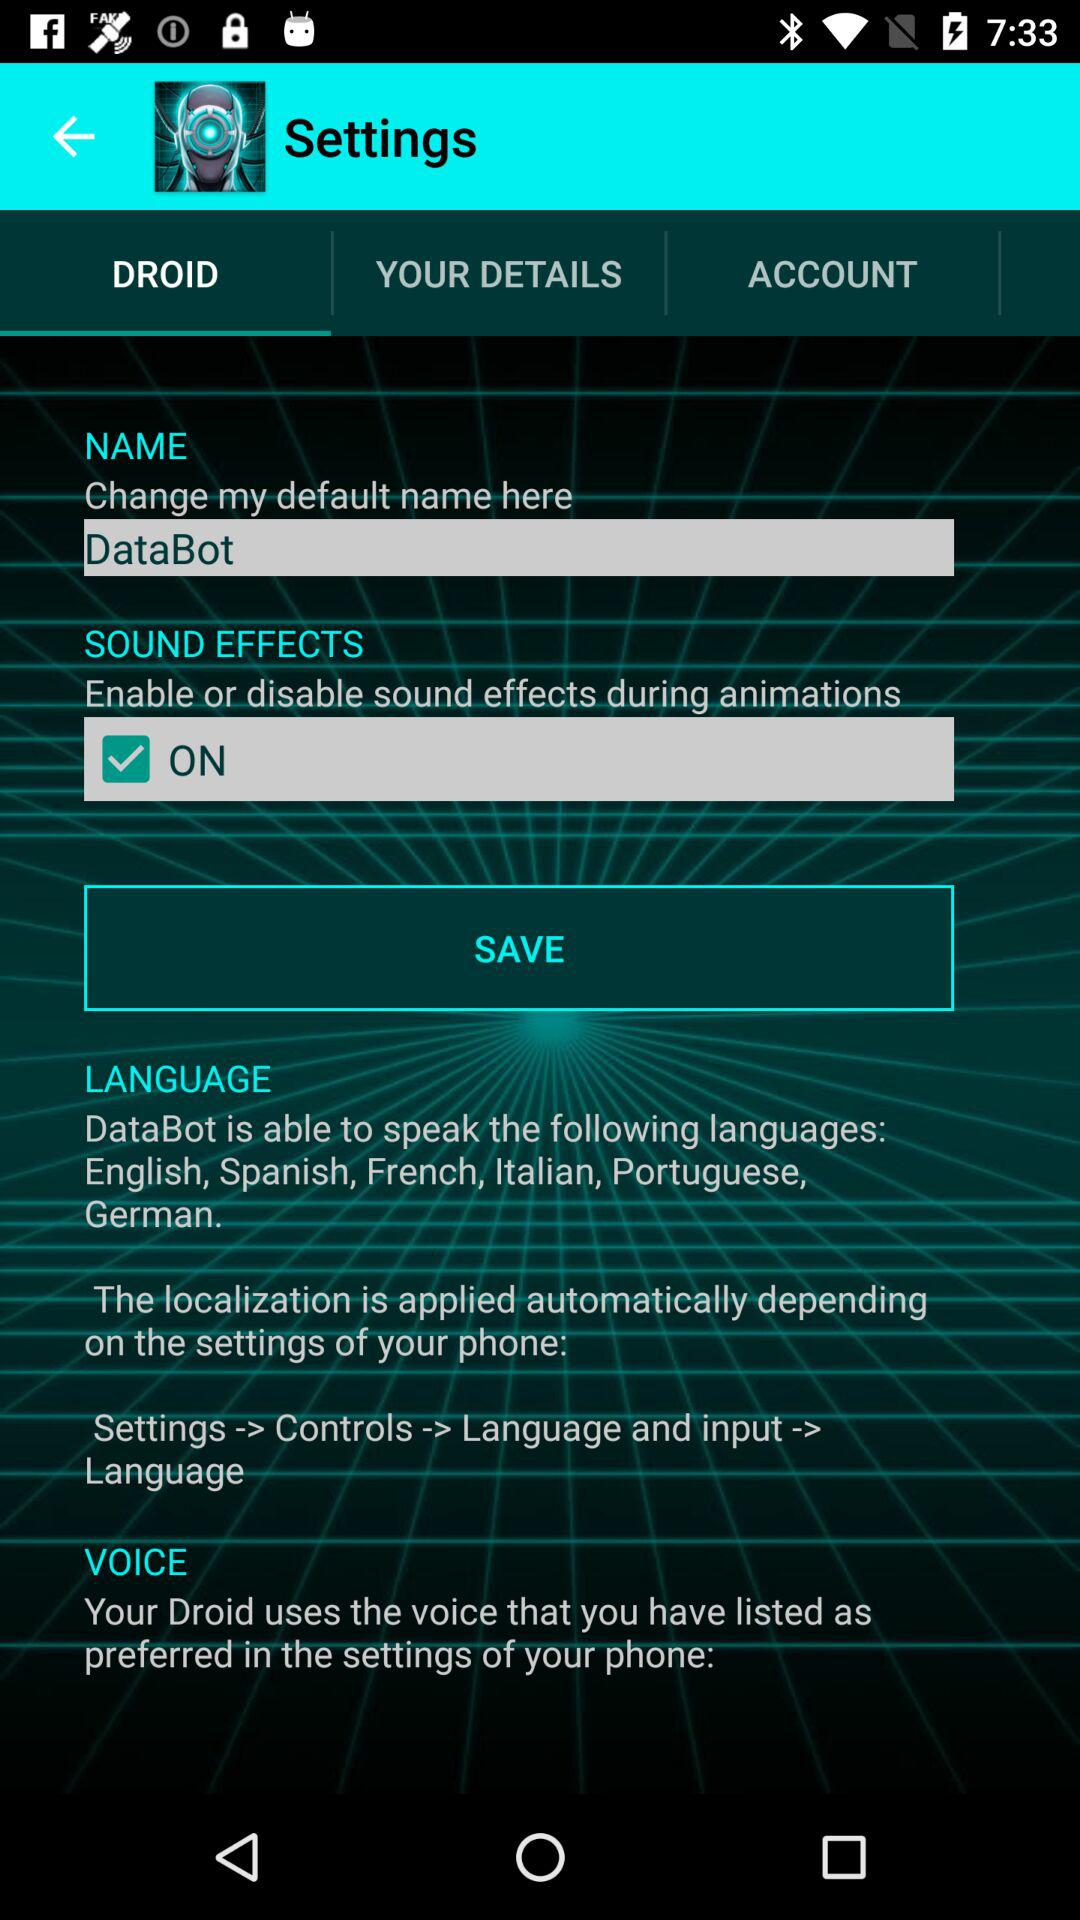What's the status of "SOUND EFFECTS"? The status is "on". 